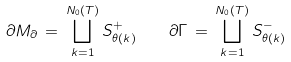Convert formula to latex. <formula><loc_0><loc_0><loc_500><loc_500>\partial M _ { \partial } \, = \, \bigsqcup _ { k = 1 } ^ { N _ { 0 } ( T ) } S _ { \theta ( k ) } ^ { + } \quad \partial \Gamma \, = \, \bigsqcup _ { k = 1 } ^ { N _ { 0 } ( T ) } S _ { \theta ( k ) } ^ { - }</formula> 